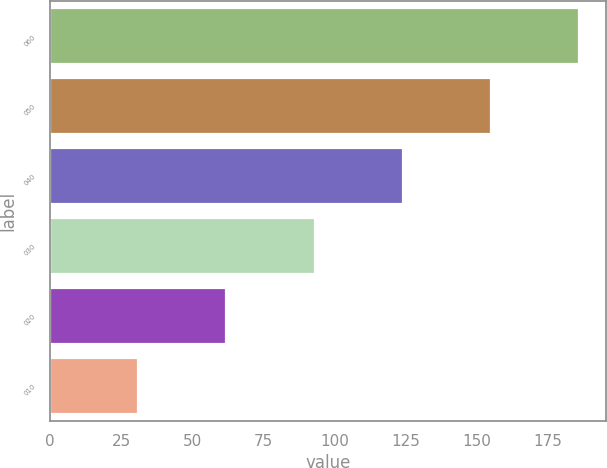Convert chart. <chart><loc_0><loc_0><loc_500><loc_500><bar_chart><fcel>060<fcel>050<fcel>040<fcel>030<fcel>020<fcel>010<nl><fcel>186<fcel>155<fcel>124<fcel>93<fcel>62<fcel>31<nl></chart> 